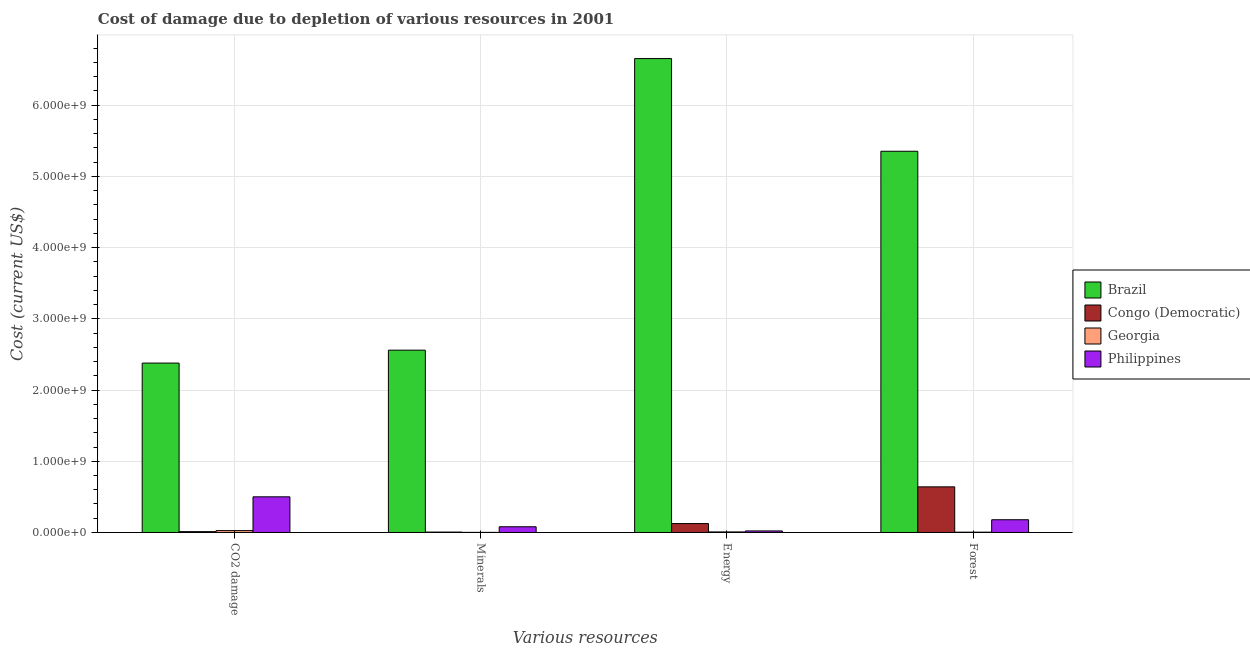How many different coloured bars are there?
Your answer should be very brief. 4. Are the number of bars on each tick of the X-axis equal?
Offer a terse response. Yes. How many bars are there on the 1st tick from the right?
Provide a short and direct response. 4. What is the label of the 4th group of bars from the left?
Offer a very short reply. Forest. What is the cost of damage due to depletion of minerals in Brazil?
Keep it short and to the point. 2.56e+09. Across all countries, what is the maximum cost of damage due to depletion of energy?
Give a very brief answer. 6.65e+09. Across all countries, what is the minimum cost of damage due to depletion of energy?
Give a very brief answer. 7.95e+06. In which country was the cost of damage due to depletion of coal maximum?
Provide a short and direct response. Brazil. In which country was the cost of damage due to depletion of forests minimum?
Give a very brief answer. Georgia. What is the total cost of damage due to depletion of coal in the graph?
Offer a very short reply. 2.92e+09. What is the difference between the cost of damage due to depletion of energy in Congo (Democratic) and that in Philippines?
Keep it short and to the point. 1.03e+08. What is the difference between the cost of damage due to depletion of coal in Brazil and the cost of damage due to depletion of forests in Philippines?
Ensure brevity in your answer.  2.20e+09. What is the average cost of damage due to depletion of energy per country?
Your answer should be very brief. 1.70e+09. What is the difference between the cost of damage due to depletion of forests and cost of damage due to depletion of energy in Philippines?
Your answer should be very brief. 1.57e+08. In how many countries, is the cost of damage due to depletion of forests greater than 5200000000 US$?
Provide a succinct answer. 1. What is the ratio of the cost of damage due to depletion of minerals in Brazil to that in Georgia?
Keep it short and to the point. 1563.46. What is the difference between the highest and the second highest cost of damage due to depletion of forests?
Offer a very short reply. 4.71e+09. What is the difference between the highest and the lowest cost of damage due to depletion of forests?
Provide a short and direct response. 5.35e+09. In how many countries, is the cost of damage due to depletion of energy greater than the average cost of damage due to depletion of energy taken over all countries?
Offer a very short reply. 1. Is it the case that in every country, the sum of the cost of damage due to depletion of forests and cost of damage due to depletion of minerals is greater than the sum of cost of damage due to depletion of coal and cost of damage due to depletion of energy?
Ensure brevity in your answer.  No. What does the 3rd bar from the left in CO2 damage represents?
Provide a short and direct response. Georgia. What does the 3rd bar from the right in Energy represents?
Offer a very short reply. Congo (Democratic). Is it the case that in every country, the sum of the cost of damage due to depletion of coal and cost of damage due to depletion of minerals is greater than the cost of damage due to depletion of energy?
Your answer should be compact. No. How many bars are there?
Your response must be concise. 16. How many countries are there in the graph?
Your answer should be compact. 4. Are the values on the major ticks of Y-axis written in scientific E-notation?
Offer a very short reply. Yes. Does the graph contain grids?
Ensure brevity in your answer.  Yes. What is the title of the graph?
Your answer should be very brief. Cost of damage due to depletion of various resources in 2001 . What is the label or title of the X-axis?
Your answer should be very brief. Various resources. What is the label or title of the Y-axis?
Your answer should be compact. Cost (current US$). What is the Cost (current US$) of Brazil in CO2 damage?
Give a very brief answer. 2.38e+09. What is the Cost (current US$) in Congo (Democratic) in CO2 damage?
Keep it short and to the point. 1.17e+07. What is the Cost (current US$) of Georgia in CO2 damage?
Keep it short and to the point. 2.66e+07. What is the Cost (current US$) of Philippines in CO2 damage?
Offer a very short reply. 5.01e+08. What is the Cost (current US$) in Brazil in Minerals?
Your answer should be compact. 2.56e+09. What is the Cost (current US$) in Congo (Democratic) in Minerals?
Offer a very short reply. 5.92e+06. What is the Cost (current US$) in Georgia in Minerals?
Offer a very short reply. 1.64e+06. What is the Cost (current US$) of Philippines in Minerals?
Give a very brief answer. 8.04e+07. What is the Cost (current US$) of Brazil in Energy?
Offer a terse response. 6.65e+09. What is the Cost (current US$) in Congo (Democratic) in Energy?
Provide a succinct answer. 1.25e+08. What is the Cost (current US$) in Georgia in Energy?
Offer a terse response. 7.95e+06. What is the Cost (current US$) of Philippines in Energy?
Offer a terse response. 2.20e+07. What is the Cost (current US$) in Brazil in Forest?
Make the answer very short. 5.35e+09. What is the Cost (current US$) in Congo (Democratic) in Forest?
Your answer should be compact. 6.41e+08. What is the Cost (current US$) in Georgia in Forest?
Provide a succinct answer. 4.43e+06. What is the Cost (current US$) in Philippines in Forest?
Your response must be concise. 1.79e+08. Across all Various resources, what is the maximum Cost (current US$) in Brazil?
Give a very brief answer. 6.65e+09. Across all Various resources, what is the maximum Cost (current US$) in Congo (Democratic)?
Ensure brevity in your answer.  6.41e+08. Across all Various resources, what is the maximum Cost (current US$) of Georgia?
Ensure brevity in your answer.  2.66e+07. Across all Various resources, what is the maximum Cost (current US$) in Philippines?
Your answer should be compact. 5.01e+08. Across all Various resources, what is the minimum Cost (current US$) of Brazil?
Your answer should be compact. 2.38e+09. Across all Various resources, what is the minimum Cost (current US$) in Congo (Democratic)?
Provide a short and direct response. 5.92e+06. Across all Various resources, what is the minimum Cost (current US$) of Georgia?
Your response must be concise. 1.64e+06. Across all Various resources, what is the minimum Cost (current US$) of Philippines?
Provide a succinct answer. 2.20e+07. What is the total Cost (current US$) in Brazil in the graph?
Provide a short and direct response. 1.69e+1. What is the total Cost (current US$) of Congo (Democratic) in the graph?
Offer a terse response. 7.84e+08. What is the total Cost (current US$) in Georgia in the graph?
Offer a terse response. 4.06e+07. What is the total Cost (current US$) of Philippines in the graph?
Keep it short and to the point. 7.82e+08. What is the difference between the Cost (current US$) in Brazil in CO2 damage and that in Minerals?
Your answer should be very brief. -1.81e+08. What is the difference between the Cost (current US$) in Congo (Democratic) in CO2 damage and that in Minerals?
Your answer should be compact. 5.82e+06. What is the difference between the Cost (current US$) in Georgia in CO2 damage and that in Minerals?
Your answer should be compact. 2.49e+07. What is the difference between the Cost (current US$) in Philippines in CO2 damage and that in Minerals?
Your answer should be very brief. 4.20e+08. What is the difference between the Cost (current US$) in Brazil in CO2 damage and that in Energy?
Keep it short and to the point. -4.28e+09. What is the difference between the Cost (current US$) in Congo (Democratic) in CO2 damage and that in Energy?
Keep it short and to the point. -1.14e+08. What is the difference between the Cost (current US$) of Georgia in CO2 damage and that in Energy?
Your answer should be compact. 1.86e+07. What is the difference between the Cost (current US$) in Philippines in CO2 damage and that in Energy?
Make the answer very short. 4.79e+08. What is the difference between the Cost (current US$) in Brazil in CO2 damage and that in Forest?
Make the answer very short. -2.97e+09. What is the difference between the Cost (current US$) of Congo (Democratic) in CO2 damage and that in Forest?
Provide a short and direct response. -6.29e+08. What is the difference between the Cost (current US$) in Georgia in CO2 damage and that in Forest?
Your answer should be very brief. 2.21e+07. What is the difference between the Cost (current US$) of Philippines in CO2 damage and that in Forest?
Provide a succinct answer. 3.22e+08. What is the difference between the Cost (current US$) in Brazil in Minerals and that in Energy?
Ensure brevity in your answer.  -4.09e+09. What is the difference between the Cost (current US$) of Congo (Democratic) in Minerals and that in Energy?
Your response must be concise. -1.19e+08. What is the difference between the Cost (current US$) of Georgia in Minerals and that in Energy?
Provide a succinct answer. -6.32e+06. What is the difference between the Cost (current US$) of Philippines in Minerals and that in Energy?
Provide a short and direct response. 5.84e+07. What is the difference between the Cost (current US$) of Brazil in Minerals and that in Forest?
Offer a terse response. -2.79e+09. What is the difference between the Cost (current US$) of Congo (Democratic) in Minerals and that in Forest?
Offer a very short reply. -6.35e+08. What is the difference between the Cost (current US$) of Georgia in Minerals and that in Forest?
Ensure brevity in your answer.  -2.79e+06. What is the difference between the Cost (current US$) of Philippines in Minerals and that in Forest?
Provide a short and direct response. -9.85e+07. What is the difference between the Cost (current US$) of Brazil in Energy and that in Forest?
Provide a succinct answer. 1.30e+09. What is the difference between the Cost (current US$) in Congo (Democratic) in Energy and that in Forest?
Your answer should be very brief. -5.15e+08. What is the difference between the Cost (current US$) in Georgia in Energy and that in Forest?
Offer a very short reply. 3.52e+06. What is the difference between the Cost (current US$) in Philippines in Energy and that in Forest?
Offer a terse response. -1.57e+08. What is the difference between the Cost (current US$) of Brazil in CO2 damage and the Cost (current US$) of Congo (Democratic) in Minerals?
Make the answer very short. 2.37e+09. What is the difference between the Cost (current US$) of Brazil in CO2 damage and the Cost (current US$) of Georgia in Minerals?
Keep it short and to the point. 2.38e+09. What is the difference between the Cost (current US$) in Brazil in CO2 damage and the Cost (current US$) in Philippines in Minerals?
Ensure brevity in your answer.  2.30e+09. What is the difference between the Cost (current US$) of Congo (Democratic) in CO2 damage and the Cost (current US$) of Georgia in Minerals?
Your answer should be compact. 1.01e+07. What is the difference between the Cost (current US$) in Congo (Democratic) in CO2 damage and the Cost (current US$) in Philippines in Minerals?
Make the answer very short. -6.86e+07. What is the difference between the Cost (current US$) of Georgia in CO2 damage and the Cost (current US$) of Philippines in Minerals?
Ensure brevity in your answer.  -5.38e+07. What is the difference between the Cost (current US$) of Brazil in CO2 damage and the Cost (current US$) of Congo (Democratic) in Energy?
Provide a short and direct response. 2.25e+09. What is the difference between the Cost (current US$) in Brazil in CO2 damage and the Cost (current US$) in Georgia in Energy?
Your answer should be very brief. 2.37e+09. What is the difference between the Cost (current US$) in Brazil in CO2 damage and the Cost (current US$) in Philippines in Energy?
Offer a very short reply. 2.36e+09. What is the difference between the Cost (current US$) in Congo (Democratic) in CO2 damage and the Cost (current US$) in Georgia in Energy?
Offer a terse response. 3.78e+06. What is the difference between the Cost (current US$) in Congo (Democratic) in CO2 damage and the Cost (current US$) in Philippines in Energy?
Give a very brief answer. -1.02e+07. What is the difference between the Cost (current US$) of Georgia in CO2 damage and the Cost (current US$) of Philippines in Energy?
Give a very brief answer. 4.60e+06. What is the difference between the Cost (current US$) in Brazil in CO2 damage and the Cost (current US$) in Congo (Democratic) in Forest?
Your answer should be compact. 1.74e+09. What is the difference between the Cost (current US$) in Brazil in CO2 damage and the Cost (current US$) in Georgia in Forest?
Ensure brevity in your answer.  2.37e+09. What is the difference between the Cost (current US$) in Brazil in CO2 damage and the Cost (current US$) in Philippines in Forest?
Offer a terse response. 2.20e+09. What is the difference between the Cost (current US$) of Congo (Democratic) in CO2 damage and the Cost (current US$) of Georgia in Forest?
Provide a short and direct response. 7.30e+06. What is the difference between the Cost (current US$) in Congo (Democratic) in CO2 damage and the Cost (current US$) in Philippines in Forest?
Give a very brief answer. -1.67e+08. What is the difference between the Cost (current US$) of Georgia in CO2 damage and the Cost (current US$) of Philippines in Forest?
Ensure brevity in your answer.  -1.52e+08. What is the difference between the Cost (current US$) in Brazil in Minerals and the Cost (current US$) in Congo (Democratic) in Energy?
Provide a succinct answer. 2.43e+09. What is the difference between the Cost (current US$) of Brazil in Minerals and the Cost (current US$) of Georgia in Energy?
Make the answer very short. 2.55e+09. What is the difference between the Cost (current US$) in Brazil in Minerals and the Cost (current US$) in Philippines in Energy?
Offer a terse response. 2.54e+09. What is the difference between the Cost (current US$) of Congo (Democratic) in Minerals and the Cost (current US$) of Georgia in Energy?
Provide a short and direct response. -2.04e+06. What is the difference between the Cost (current US$) of Congo (Democratic) in Minerals and the Cost (current US$) of Philippines in Energy?
Give a very brief answer. -1.60e+07. What is the difference between the Cost (current US$) in Georgia in Minerals and the Cost (current US$) in Philippines in Energy?
Provide a succinct answer. -2.03e+07. What is the difference between the Cost (current US$) of Brazil in Minerals and the Cost (current US$) of Congo (Democratic) in Forest?
Ensure brevity in your answer.  1.92e+09. What is the difference between the Cost (current US$) in Brazil in Minerals and the Cost (current US$) in Georgia in Forest?
Make the answer very short. 2.56e+09. What is the difference between the Cost (current US$) in Brazil in Minerals and the Cost (current US$) in Philippines in Forest?
Ensure brevity in your answer.  2.38e+09. What is the difference between the Cost (current US$) of Congo (Democratic) in Minerals and the Cost (current US$) of Georgia in Forest?
Give a very brief answer. 1.49e+06. What is the difference between the Cost (current US$) in Congo (Democratic) in Minerals and the Cost (current US$) in Philippines in Forest?
Provide a succinct answer. -1.73e+08. What is the difference between the Cost (current US$) in Georgia in Minerals and the Cost (current US$) in Philippines in Forest?
Make the answer very short. -1.77e+08. What is the difference between the Cost (current US$) in Brazil in Energy and the Cost (current US$) in Congo (Democratic) in Forest?
Your answer should be very brief. 6.01e+09. What is the difference between the Cost (current US$) of Brazil in Energy and the Cost (current US$) of Georgia in Forest?
Ensure brevity in your answer.  6.65e+09. What is the difference between the Cost (current US$) of Brazil in Energy and the Cost (current US$) of Philippines in Forest?
Ensure brevity in your answer.  6.47e+09. What is the difference between the Cost (current US$) in Congo (Democratic) in Energy and the Cost (current US$) in Georgia in Forest?
Offer a terse response. 1.21e+08. What is the difference between the Cost (current US$) of Congo (Democratic) in Energy and the Cost (current US$) of Philippines in Forest?
Give a very brief answer. -5.37e+07. What is the difference between the Cost (current US$) of Georgia in Energy and the Cost (current US$) of Philippines in Forest?
Make the answer very short. -1.71e+08. What is the average Cost (current US$) of Brazil per Various resources?
Provide a short and direct response. 4.24e+09. What is the average Cost (current US$) in Congo (Democratic) per Various resources?
Give a very brief answer. 1.96e+08. What is the average Cost (current US$) in Georgia per Various resources?
Provide a succinct answer. 1.01e+07. What is the average Cost (current US$) in Philippines per Various resources?
Offer a very short reply. 1.95e+08. What is the difference between the Cost (current US$) in Brazil and Cost (current US$) in Congo (Democratic) in CO2 damage?
Offer a very short reply. 2.37e+09. What is the difference between the Cost (current US$) of Brazil and Cost (current US$) of Georgia in CO2 damage?
Your answer should be very brief. 2.35e+09. What is the difference between the Cost (current US$) of Brazil and Cost (current US$) of Philippines in CO2 damage?
Your answer should be very brief. 1.88e+09. What is the difference between the Cost (current US$) of Congo (Democratic) and Cost (current US$) of Georgia in CO2 damage?
Ensure brevity in your answer.  -1.48e+07. What is the difference between the Cost (current US$) of Congo (Democratic) and Cost (current US$) of Philippines in CO2 damage?
Keep it short and to the point. -4.89e+08. What is the difference between the Cost (current US$) of Georgia and Cost (current US$) of Philippines in CO2 damage?
Offer a very short reply. -4.74e+08. What is the difference between the Cost (current US$) in Brazil and Cost (current US$) in Congo (Democratic) in Minerals?
Keep it short and to the point. 2.55e+09. What is the difference between the Cost (current US$) of Brazil and Cost (current US$) of Georgia in Minerals?
Ensure brevity in your answer.  2.56e+09. What is the difference between the Cost (current US$) in Brazil and Cost (current US$) in Philippines in Minerals?
Offer a very short reply. 2.48e+09. What is the difference between the Cost (current US$) of Congo (Democratic) and Cost (current US$) of Georgia in Minerals?
Provide a succinct answer. 4.28e+06. What is the difference between the Cost (current US$) of Congo (Democratic) and Cost (current US$) of Philippines in Minerals?
Ensure brevity in your answer.  -7.45e+07. What is the difference between the Cost (current US$) of Georgia and Cost (current US$) of Philippines in Minerals?
Your response must be concise. -7.87e+07. What is the difference between the Cost (current US$) in Brazil and Cost (current US$) in Congo (Democratic) in Energy?
Give a very brief answer. 6.53e+09. What is the difference between the Cost (current US$) in Brazil and Cost (current US$) in Georgia in Energy?
Give a very brief answer. 6.65e+09. What is the difference between the Cost (current US$) of Brazil and Cost (current US$) of Philippines in Energy?
Give a very brief answer. 6.63e+09. What is the difference between the Cost (current US$) in Congo (Democratic) and Cost (current US$) in Georgia in Energy?
Your answer should be compact. 1.17e+08. What is the difference between the Cost (current US$) in Congo (Democratic) and Cost (current US$) in Philippines in Energy?
Give a very brief answer. 1.03e+08. What is the difference between the Cost (current US$) in Georgia and Cost (current US$) in Philippines in Energy?
Keep it short and to the point. -1.40e+07. What is the difference between the Cost (current US$) of Brazil and Cost (current US$) of Congo (Democratic) in Forest?
Your answer should be very brief. 4.71e+09. What is the difference between the Cost (current US$) of Brazil and Cost (current US$) of Georgia in Forest?
Provide a succinct answer. 5.35e+09. What is the difference between the Cost (current US$) in Brazil and Cost (current US$) in Philippines in Forest?
Give a very brief answer. 5.17e+09. What is the difference between the Cost (current US$) of Congo (Democratic) and Cost (current US$) of Georgia in Forest?
Make the answer very short. 6.36e+08. What is the difference between the Cost (current US$) of Congo (Democratic) and Cost (current US$) of Philippines in Forest?
Offer a terse response. 4.62e+08. What is the difference between the Cost (current US$) in Georgia and Cost (current US$) in Philippines in Forest?
Provide a short and direct response. -1.74e+08. What is the ratio of the Cost (current US$) of Brazil in CO2 damage to that in Minerals?
Your answer should be compact. 0.93. What is the ratio of the Cost (current US$) in Congo (Democratic) in CO2 damage to that in Minerals?
Offer a terse response. 1.98. What is the ratio of the Cost (current US$) of Georgia in CO2 damage to that in Minerals?
Your answer should be very brief. 16.23. What is the ratio of the Cost (current US$) of Philippines in CO2 damage to that in Minerals?
Provide a short and direct response. 6.23. What is the ratio of the Cost (current US$) of Brazil in CO2 damage to that in Energy?
Ensure brevity in your answer.  0.36. What is the ratio of the Cost (current US$) of Congo (Democratic) in CO2 damage to that in Energy?
Your answer should be very brief. 0.09. What is the ratio of the Cost (current US$) in Georgia in CO2 damage to that in Energy?
Keep it short and to the point. 3.34. What is the ratio of the Cost (current US$) in Philippines in CO2 damage to that in Energy?
Your answer should be very brief. 22.8. What is the ratio of the Cost (current US$) in Brazil in CO2 damage to that in Forest?
Make the answer very short. 0.44. What is the ratio of the Cost (current US$) of Congo (Democratic) in CO2 damage to that in Forest?
Your answer should be compact. 0.02. What is the ratio of the Cost (current US$) of Georgia in CO2 damage to that in Forest?
Provide a succinct answer. 6. What is the ratio of the Cost (current US$) of Philippines in CO2 damage to that in Forest?
Offer a very short reply. 2.8. What is the ratio of the Cost (current US$) of Brazil in Minerals to that in Energy?
Your answer should be very brief. 0.38. What is the ratio of the Cost (current US$) in Congo (Democratic) in Minerals to that in Energy?
Make the answer very short. 0.05. What is the ratio of the Cost (current US$) of Georgia in Minerals to that in Energy?
Your answer should be compact. 0.21. What is the ratio of the Cost (current US$) of Philippines in Minerals to that in Energy?
Ensure brevity in your answer.  3.66. What is the ratio of the Cost (current US$) in Brazil in Minerals to that in Forest?
Your answer should be very brief. 0.48. What is the ratio of the Cost (current US$) of Congo (Democratic) in Minerals to that in Forest?
Provide a short and direct response. 0.01. What is the ratio of the Cost (current US$) in Georgia in Minerals to that in Forest?
Make the answer very short. 0.37. What is the ratio of the Cost (current US$) of Philippines in Minerals to that in Forest?
Provide a short and direct response. 0.45. What is the ratio of the Cost (current US$) in Brazil in Energy to that in Forest?
Offer a terse response. 1.24. What is the ratio of the Cost (current US$) of Congo (Democratic) in Energy to that in Forest?
Your answer should be very brief. 0.2. What is the ratio of the Cost (current US$) of Georgia in Energy to that in Forest?
Provide a succinct answer. 1.8. What is the ratio of the Cost (current US$) in Philippines in Energy to that in Forest?
Your answer should be very brief. 0.12. What is the difference between the highest and the second highest Cost (current US$) in Brazil?
Your answer should be compact. 1.30e+09. What is the difference between the highest and the second highest Cost (current US$) in Congo (Democratic)?
Keep it short and to the point. 5.15e+08. What is the difference between the highest and the second highest Cost (current US$) in Georgia?
Offer a very short reply. 1.86e+07. What is the difference between the highest and the second highest Cost (current US$) in Philippines?
Keep it short and to the point. 3.22e+08. What is the difference between the highest and the lowest Cost (current US$) in Brazil?
Provide a short and direct response. 4.28e+09. What is the difference between the highest and the lowest Cost (current US$) in Congo (Democratic)?
Offer a very short reply. 6.35e+08. What is the difference between the highest and the lowest Cost (current US$) of Georgia?
Your answer should be compact. 2.49e+07. What is the difference between the highest and the lowest Cost (current US$) in Philippines?
Offer a very short reply. 4.79e+08. 